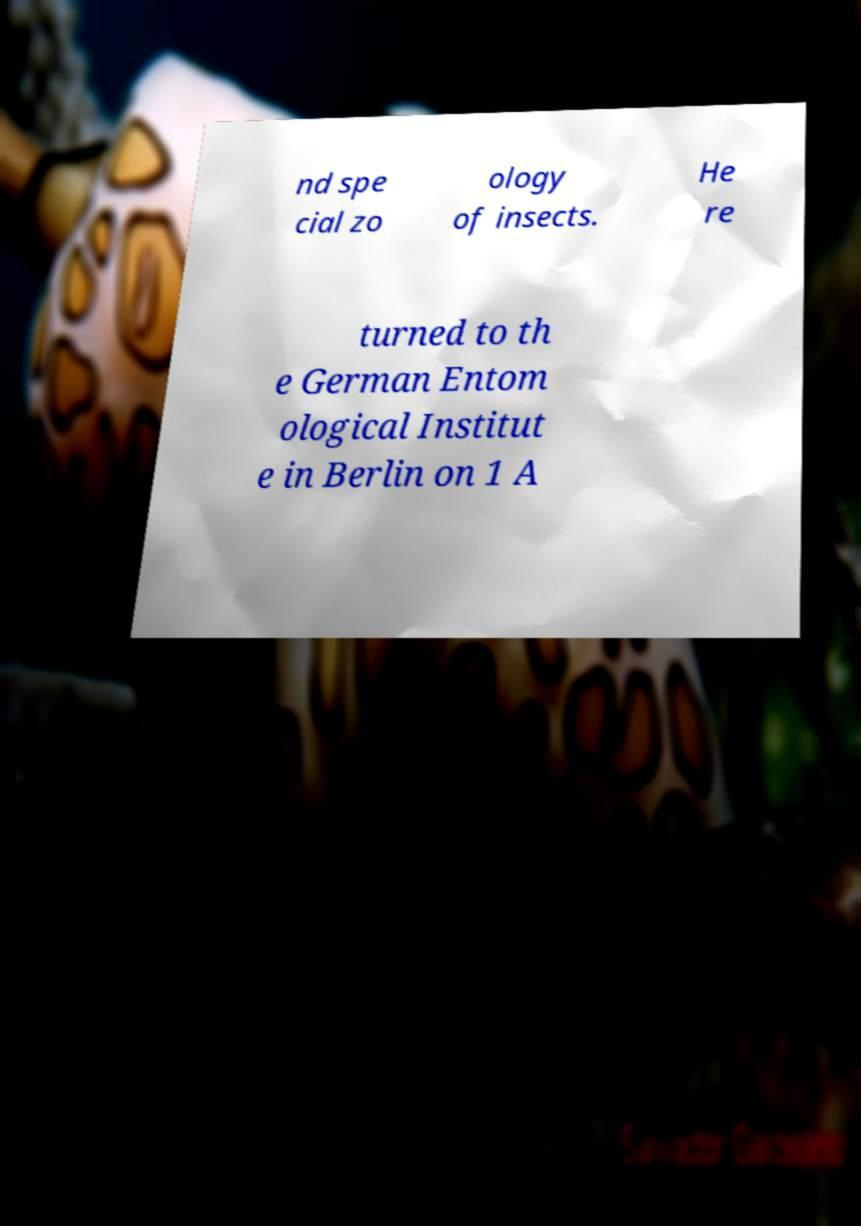I need the written content from this picture converted into text. Can you do that? nd spe cial zo ology of insects. He re turned to th e German Entom ological Institut e in Berlin on 1 A 